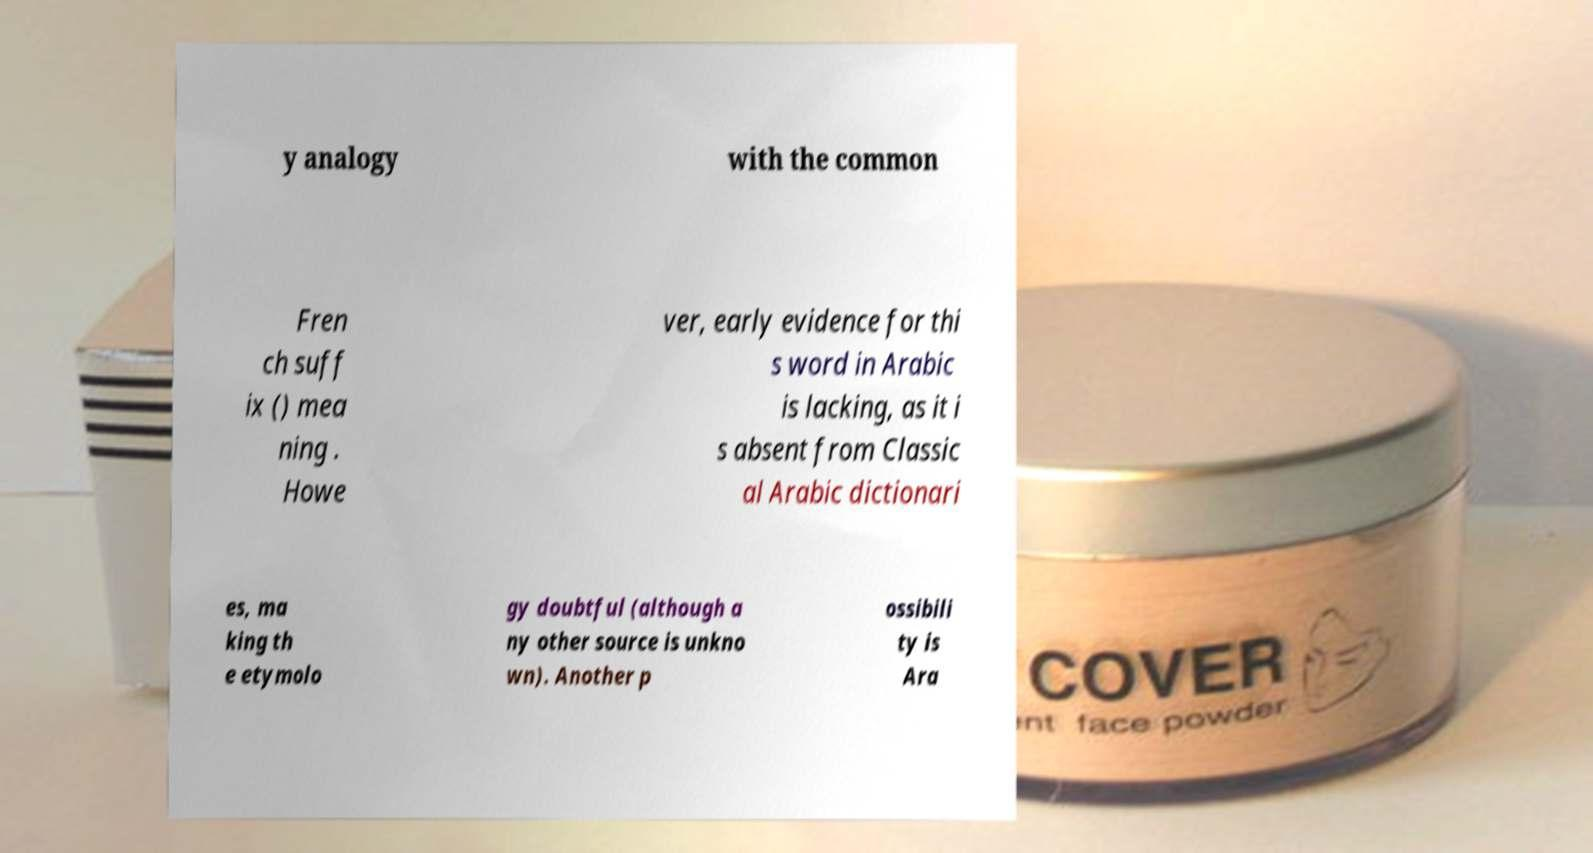What messages or text are displayed in this image? I need them in a readable, typed format. y analogy with the common Fren ch suff ix () mea ning . Howe ver, early evidence for thi s word in Arabic is lacking, as it i s absent from Classic al Arabic dictionari es, ma king th e etymolo gy doubtful (although a ny other source is unkno wn). Another p ossibili ty is Ara 